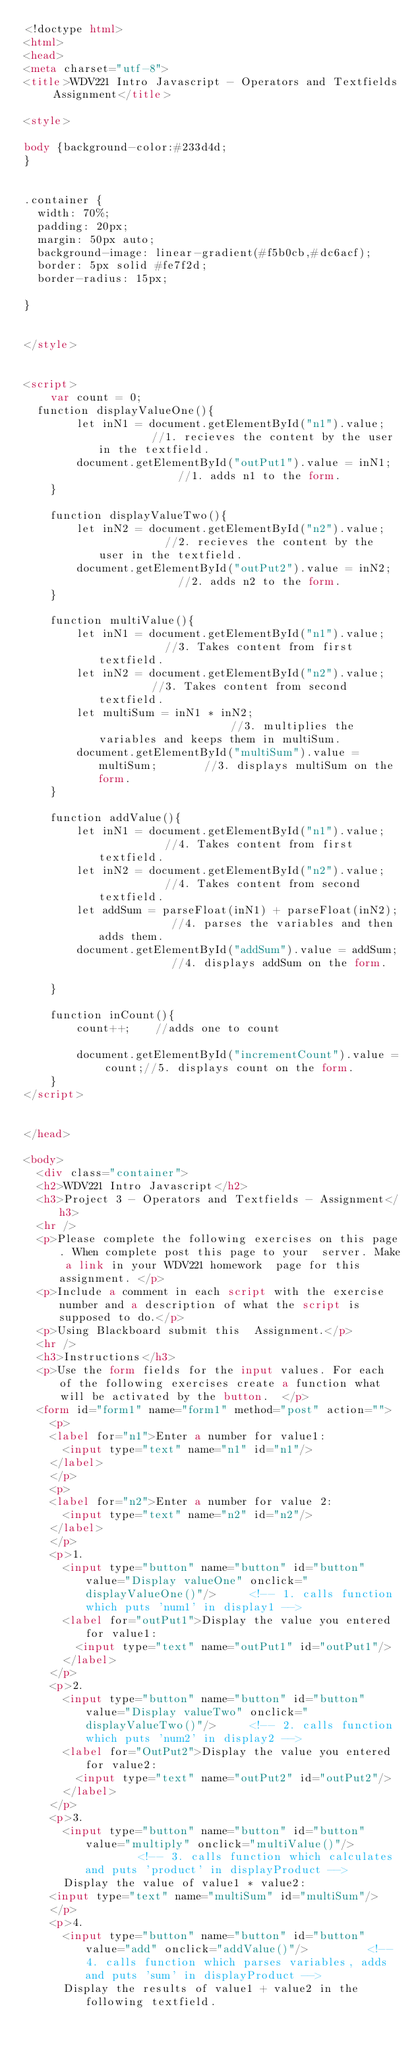Convert code to text. <code><loc_0><loc_0><loc_500><loc_500><_HTML_><!doctype html>
<html>
<head>
<meta charset="utf-8">
<title>WDV221 Intro Javascript - Operators and Textfields Assignment</title>

<style>

body {background-color:#233d4d;
}


.container {
  width: 70%;
  padding: 20px;
  margin: 50px auto;
  background-image: linear-gradient(#f5b0cb,#dc6acf);
  border: 5px solid #fe7f2d;
  border-radius: 15px;

}


</style>


<script>
	var count = 0;	
  function displayValueOne(){
		let inN1 = document.getElementById("n1").value;	      	//1. recieves the content by the user in the textfield.
		document.getElementById("outPut1").value = inN1;		    //1. adds n1 to the form. 
	}

	function displayValueTwo(){
		let inN2 = document.getElementById("n2").value;		      //2. recieves the content by the user in the textfield.	
		document.getElementById("outPut2").value = inN2;	    	//2. adds n2 to the form.
	}

	function multiValue(){
		let inN1 = document.getElementById("n1").value;		      //3. Takes content from first textfield.
		let inN2 = document.getElementById("n2").value;	       	//3. Takes content from second textfield.
		let multiSum = inN1 * inN2;							                //3. multiplies the variables and keeps them in multiSum.
		document.getElementById("multiSum").value = multiSum;		//3. displays multiSum on the form.	
	}
	
	function addValue(){
		let inN1 = document.getElementById("n1").value;		      //4. Takes content from first textfield.
		let inN2 = document.getElementById("n2").value;		      //4. Takes content from second textfield.
		let addSum = parseFloat(inN1) + parseFloat(inN2);		    //4. parses the variables and then adds them.
		document.getElementById("addSum").value = addSum;	    	//4. displays addSum on the form.	
	}
	
	function inCount(){
		count++;	//adds one to count 												
		document.getElementById("incrementCount").value = count;//5. displays count on the form.
	}
</script>


</head>

<body>
  <div class="container">
  <h2>WDV221 Intro Javascript</h2>
  <h3>Project 3 - Operators and Textfields - Assignment</h3>
  <hr />
  <p>Please complete the following exercises on this page. When complete post this page to your  server. Make a link in your WDV221 homework  page for this assignment. </p>
  <p>Include a comment in each script with the exercise number and a description of what the script is supposed to do.</p>
  <p>Using Blackboard submit this  Assignment.</p>
  <hr />
  <h3>Instructions</h3>
  <p>Use the form fields for the input values. For each of the following exercises create a function what will be activated by the button.  </p>
  <form id="form1" name="form1" method="post" action="">
    <p>
    <label for="n1">Enter a number for value1:
      <input type="text" name="n1" id="n1"/>
    </label>	
    </p>
    <p>
    <label for="n2">Enter a number for value 2:
      <input type="text" name="n2" id="n2"/>
    </label>	
    </p>
    <p>1.
      <input type="button" name="button" id="button" value="Display valueOne" onclick="displayValueOne()"/>		<!-- 1. calls function which puts 'num1' in display1 -->
      <label for="outPut1">Display the value you entered for value1:
        <input type="text" name="outPut1" id="outPut1"/>
      </label>	
    </p>
    <p>2.
      <input type="button" name="button" id="button" value="Display valueTwo" onclick="displayValueTwo()"/>		<!-- 2. calls function which puts 'num2' in display2 -->
      <label for="OutPut2">Display the value you entered for value2:
        <input type="text" name="outPut2" id="outPut2"/>
      </label>	
    </p>
    <p>3.
      <input type="button" name="button" id="button" value="multiply" onclick="multiValue()"/>				<!-- 3. calls function which calculates and puts 'product' in displayProduct -->
      Display the value of value1 * value2:
    <input type="text" name="multiSum" id="multiSum"/>
    </p>
    <p>4.
      <input type="button" name="button" id="button" value="add" onclick="addValue()"/>			<!-- 4. calls function which parses variables, adds and puts 'sum' in displayProduct -->
      Display the results of value1 + value2 in the following textfield.</code> 